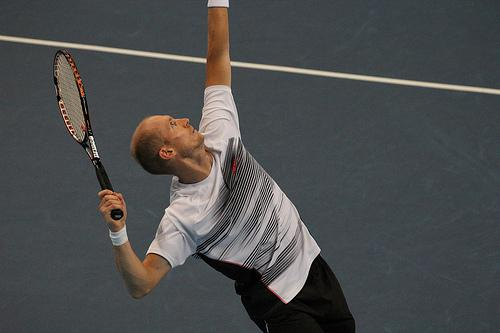Question: what is the man doing?
Choices:
A. Playing.
B. Running.
C. Jumping.
D. Throwing.
Answer with the letter. Answer: A Question: why is the photo clear?
Choices:
A. It is bright.
B. It is sunny.
C. It is not foggy.
D. It's daytime.
Answer with the letter. Answer: D Question: when was the man looking up?
Choices:
A. After hitting the ball.
B. During his swing.
C. Before getting set to hit the ball.
D. When about to hit the ball.
Answer with the letter. Answer: D Question: what is the man holding?
Choices:
A. A baseball bat.
B. A football.
C. A tennis racket.
D. A basketball.
Answer with the letter. Answer: C 